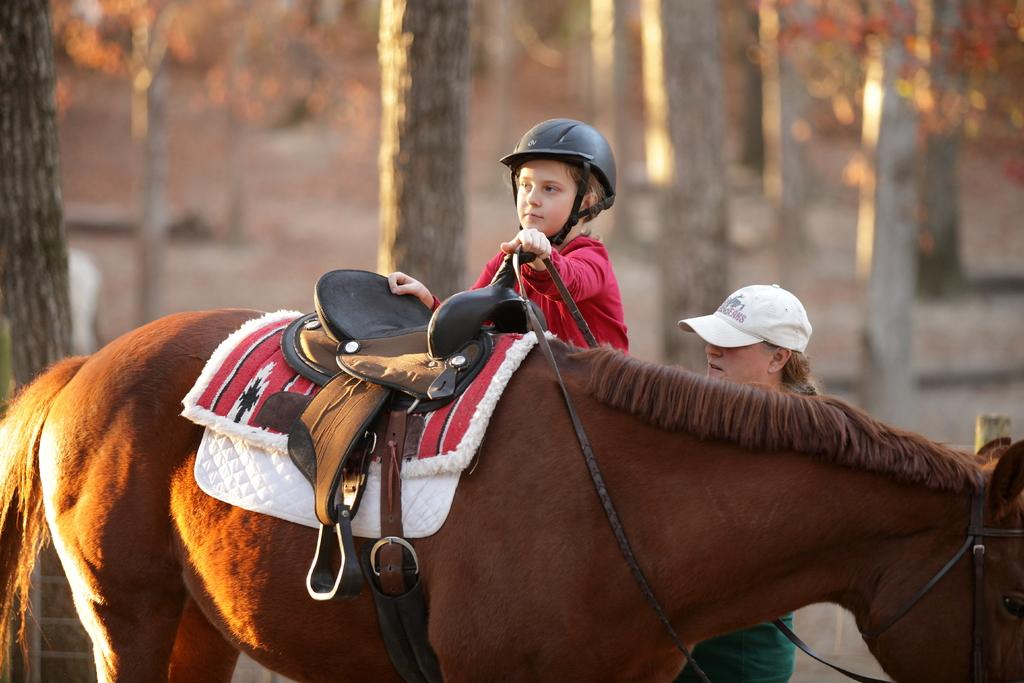What animal is present in the image? There is a horse in the image. What is the person on the left side of the image doing? One person is holding the horse's belt. How many people are in the image? There are two persons in the image. What can be seen in the background of the image? There are trees in the background of the image. What type of drink is being served on the scale in the image? There is no scale or drink present in the image; it features a horse and two people. 